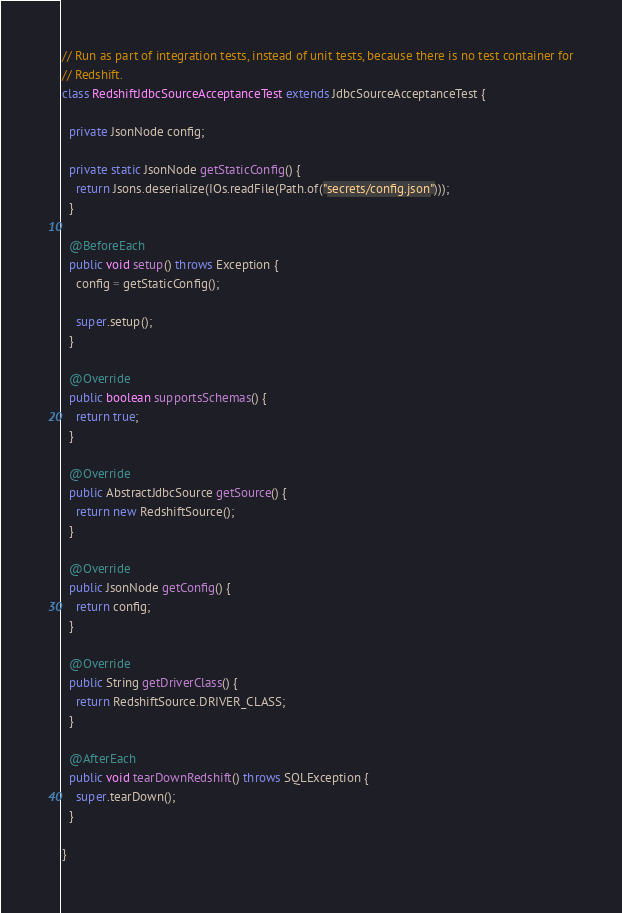<code> <loc_0><loc_0><loc_500><loc_500><_Java_>
// Run as part of integration tests, instead of unit tests, because there is no test container for
// Redshift.
class RedshiftJdbcSourceAcceptanceTest extends JdbcSourceAcceptanceTest {

  private JsonNode config;

  private static JsonNode getStaticConfig() {
    return Jsons.deserialize(IOs.readFile(Path.of("secrets/config.json")));
  }

  @BeforeEach
  public void setup() throws Exception {
    config = getStaticConfig();

    super.setup();
  }

  @Override
  public boolean supportsSchemas() {
    return true;
  }

  @Override
  public AbstractJdbcSource getSource() {
    return new RedshiftSource();
  }

  @Override
  public JsonNode getConfig() {
    return config;
  }

  @Override
  public String getDriverClass() {
    return RedshiftSource.DRIVER_CLASS;
  }

  @AfterEach
  public void tearDownRedshift() throws SQLException {
    super.tearDown();
  }

}
</code> 